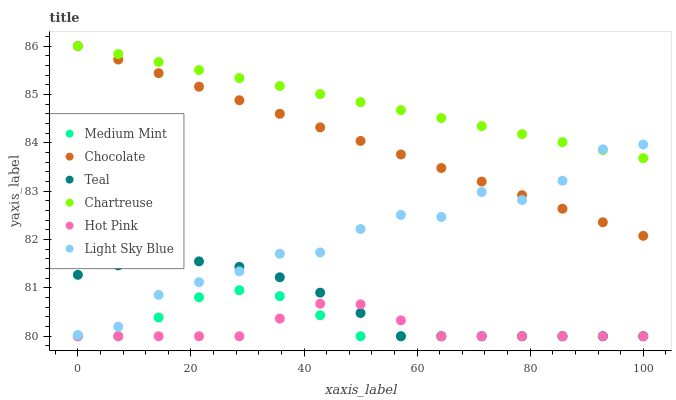Does Hot Pink have the minimum area under the curve?
Answer yes or no. Yes. Does Chartreuse have the maximum area under the curve?
Answer yes or no. Yes. Does Chocolate have the minimum area under the curve?
Answer yes or no. No. Does Chocolate have the maximum area under the curve?
Answer yes or no. No. Is Chocolate the smoothest?
Answer yes or no. Yes. Is Light Sky Blue the roughest?
Answer yes or no. Yes. Is Hot Pink the smoothest?
Answer yes or no. No. Is Hot Pink the roughest?
Answer yes or no. No. Does Medium Mint have the lowest value?
Answer yes or no. Yes. Does Chocolate have the lowest value?
Answer yes or no. No. Does Chartreuse have the highest value?
Answer yes or no. Yes. Does Hot Pink have the highest value?
Answer yes or no. No. Is Teal less than Chocolate?
Answer yes or no. Yes. Is Chartreuse greater than Hot Pink?
Answer yes or no. Yes. Does Chocolate intersect Light Sky Blue?
Answer yes or no. Yes. Is Chocolate less than Light Sky Blue?
Answer yes or no. No. Is Chocolate greater than Light Sky Blue?
Answer yes or no. No. Does Teal intersect Chocolate?
Answer yes or no. No. 